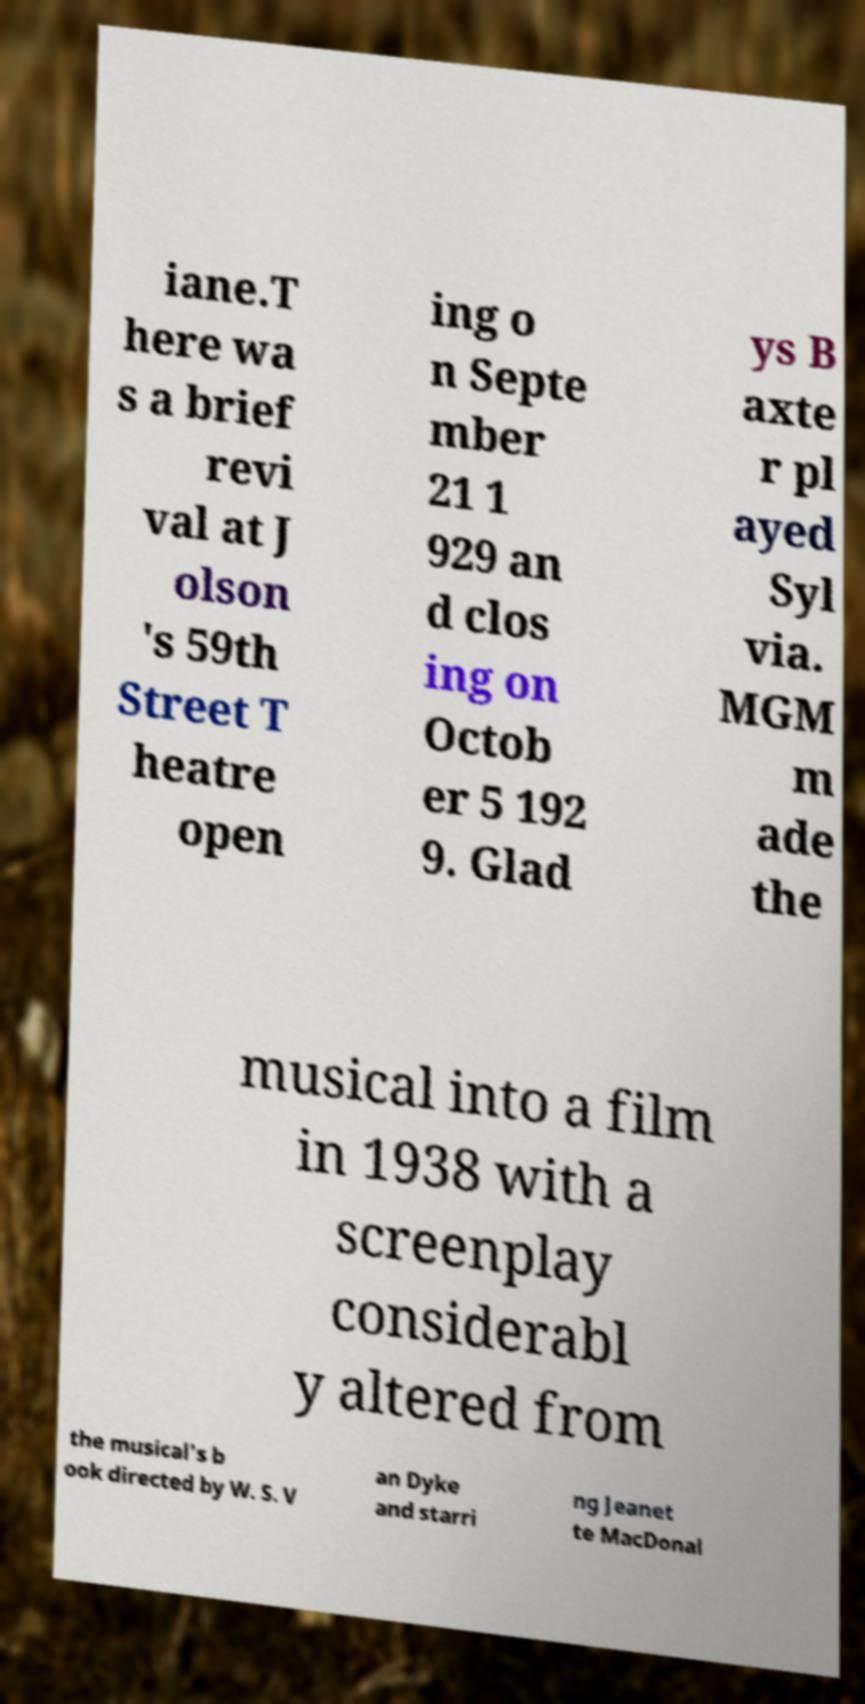I need the written content from this picture converted into text. Can you do that? iane.T here wa s a brief revi val at J olson 's 59th Street T heatre open ing o n Septe mber 21 1 929 an d clos ing on Octob er 5 192 9. Glad ys B axte r pl ayed Syl via. MGM m ade the musical into a film in 1938 with a screenplay considerabl y altered from the musical's b ook directed by W. S. V an Dyke and starri ng Jeanet te MacDonal 